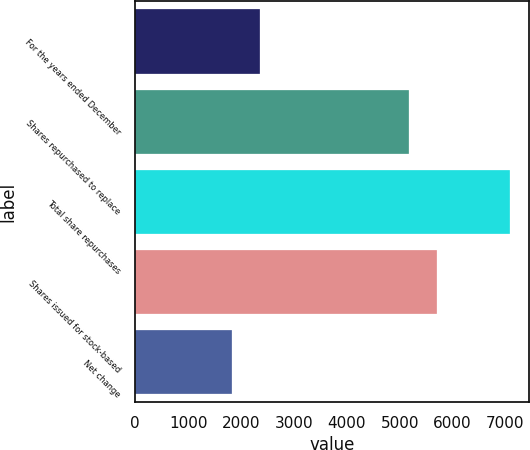<chart> <loc_0><loc_0><loc_500><loc_500><bar_chart><fcel>For the years ended December<fcel>Shares repurchased to replace<fcel>Total share repurchases<fcel>Shares issued for stock-based<fcel>Net change<nl><fcel>2349.8<fcel>5179<fcel>7082<fcel>5704.8<fcel>1824<nl></chart> 